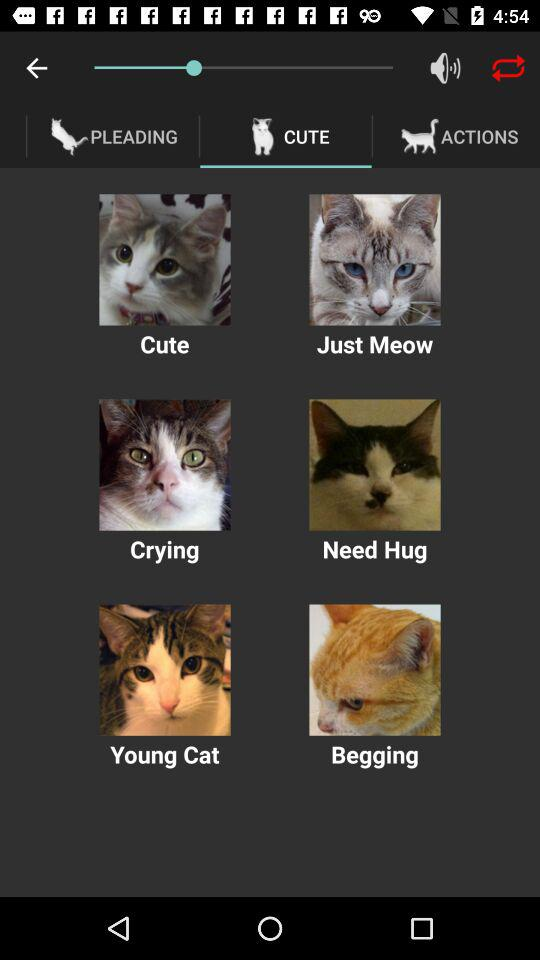Which tab is selected? The selected tab is "CUTE". 